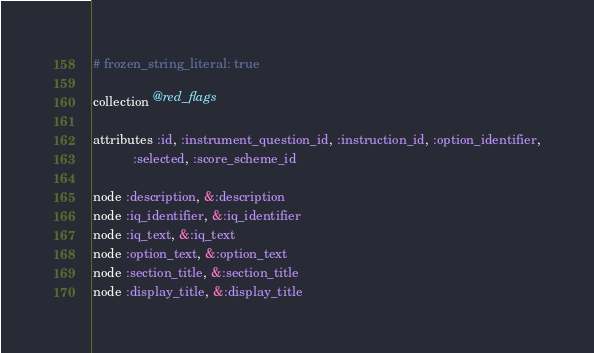Convert code to text. <code><loc_0><loc_0><loc_500><loc_500><_Ruby_># frozen_string_literal: true

collection @red_flags

attributes :id, :instrument_question_id, :instruction_id, :option_identifier,
           :selected, :score_scheme_id

node :description, &:description
node :iq_identifier, &:iq_identifier
node :iq_text, &:iq_text
node :option_text, &:option_text
node :section_title, &:section_title
node :display_title, &:display_title
</code> 